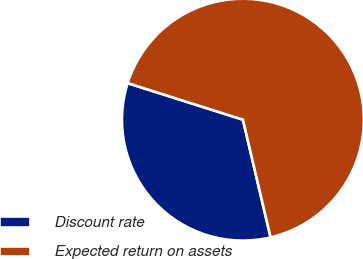Convert chart. <chart><loc_0><loc_0><loc_500><loc_500><pie_chart><fcel>Discount rate<fcel>Expected return on assets<nl><fcel>33.56%<fcel>66.44%<nl></chart> 